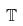Convert formula to latex. <formula><loc_0><loc_0><loc_500><loc_500>\mathbb { T }</formula> 